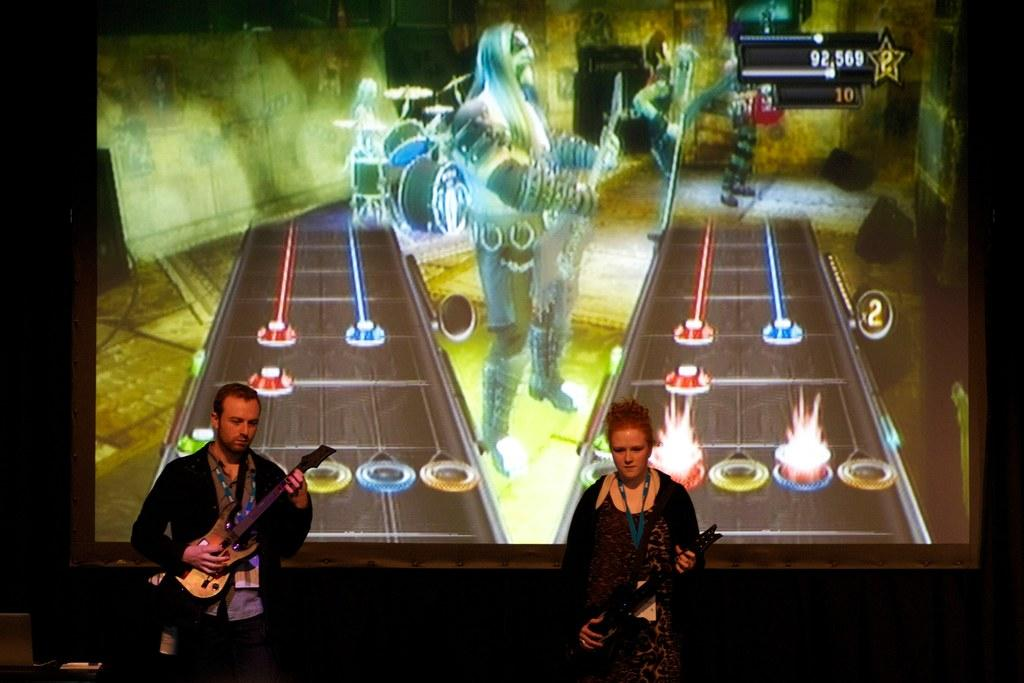How many people are in the image? There are two persons in the image. What are the persons doing in the image? The persons are standing and holding musical instruments in their hands. What can be seen in the background of the image? There is a huge screen in the background of the image. What type of land can be seen in the image? There is no land visible in the image; it features two people holding musical instruments and a huge screen in the background. How do the frogs contribute to the pleasure of the people in the image? There are no frogs present in the image, so it is not possible to determine their contribution to the pleasure of the people. 